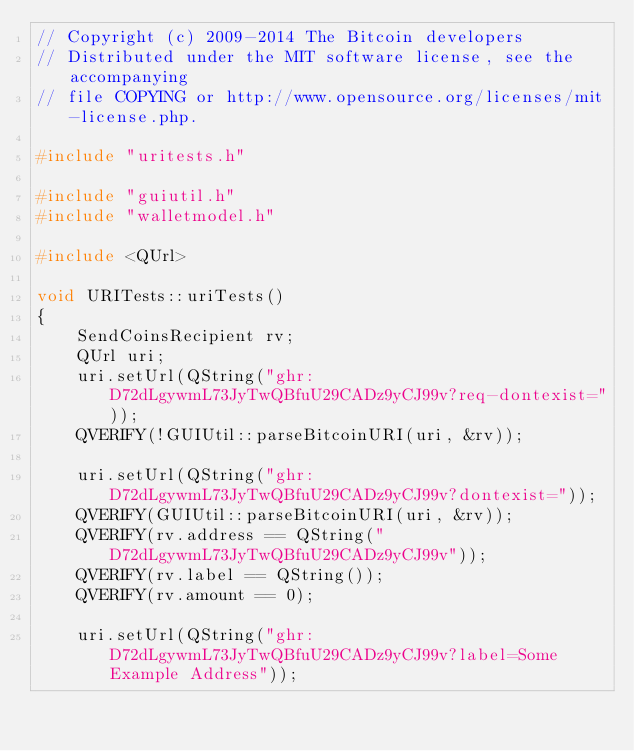<code> <loc_0><loc_0><loc_500><loc_500><_C++_>// Copyright (c) 2009-2014 The Bitcoin developers
// Distributed under the MIT software license, see the accompanying
// file COPYING or http://www.opensource.org/licenses/mit-license.php.

#include "uritests.h"

#include "guiutil.h"
#include "walletmodel.h"

#include <QUrl>

void URITests::uriTests()
{
    SendCoinsRecipient rv;
    QUrl uri;
    uri.setUrl(QString("ghr:D72dLgywmL73JyTwQBfuU29CADz9yCJ99v?req-dontexist="));
    QVERIFY(!GUIUtil::parseBitcoinURI(uri, &rv));

    uri.setUrl(QString("ghr:D72dLgywmL73JyTwQBfuU29CADz9yCJ99v?dontexist="));
    QVERIFY(GUIUtil::parseBitcoinURI(uri, &rv));
    QVERIFY(rv.address == QString("D72dLgywmL73JyTwQBfuU29CADz9yCJ99v"));
    QVERIFY(rv.label == QString());
    QVERIFY(rv.amount == 0);

    uri.setUrl(QString("ghr:D72dLgywmL73JyTwQBfuU29CADz9yCJ99v?label=Some Example Address"));</code> 